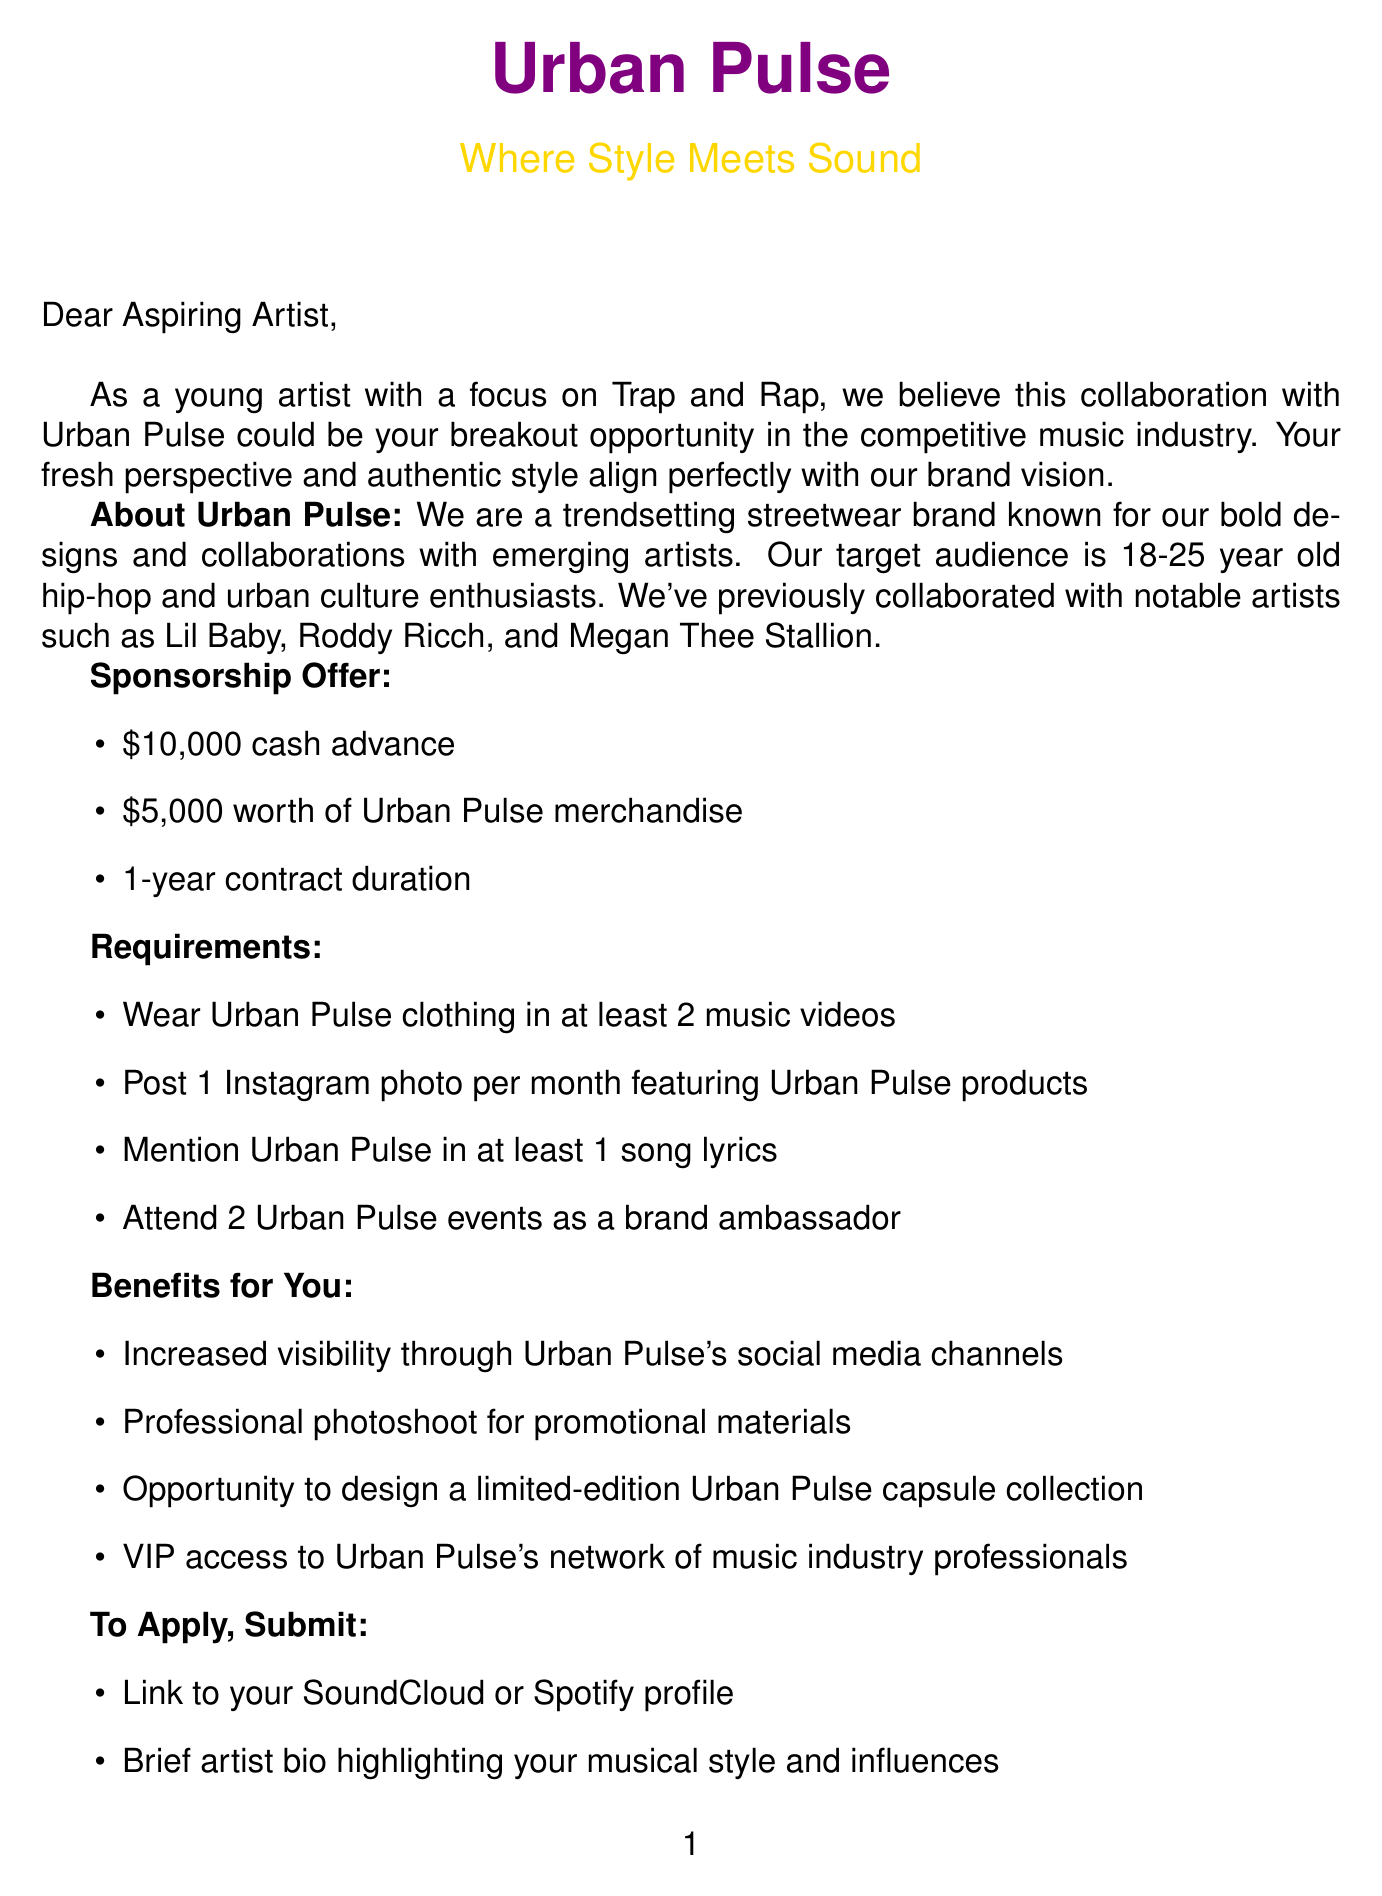what is the name of the brand? The name of the brand mentioned in the document is Urban Pulse.
Answer: Urban Pulse what is the cash advance offered? The cash advance provided in the sponsorship offer is stated as $10,000.
Answer: $10,000 how many music videos must an artist wear Urban Pulse clothing in? The requirements specify that an artist must wear Urban Pulse clothing in at least 2 music videos.
Answer: 2 music videos who is the Artist Relations Manager? The document names Jasmine Rodriguez as the Artist Relations Manager.
Answer: Jasmine Rodriguez when is the application deadline? The application deadline for the sponsorship is August 15, 2023.
Answer: August 15, 2023 list one notable collaboration by Urban Pulse. The document mentions several notable collaborations including Lil Baby.
Answer: Lil Baby what is one benefit for the artist if selected? One of the benefits listed for the artist is increased visibility through Urban Pulse's social media channels.
Answer: Increased visibility how many Instagram photos must the artist post per month? The requirement states that the artist must post 1 Instagram photo per month featuring Urban Pulse products.
Answer: 1 photo what must the artist submit to apply? The artist must provide a link to their SoundCloud or Spotify profile as part of the submission requirements.
Answer: Link to SoundCloud or Spotify profile 